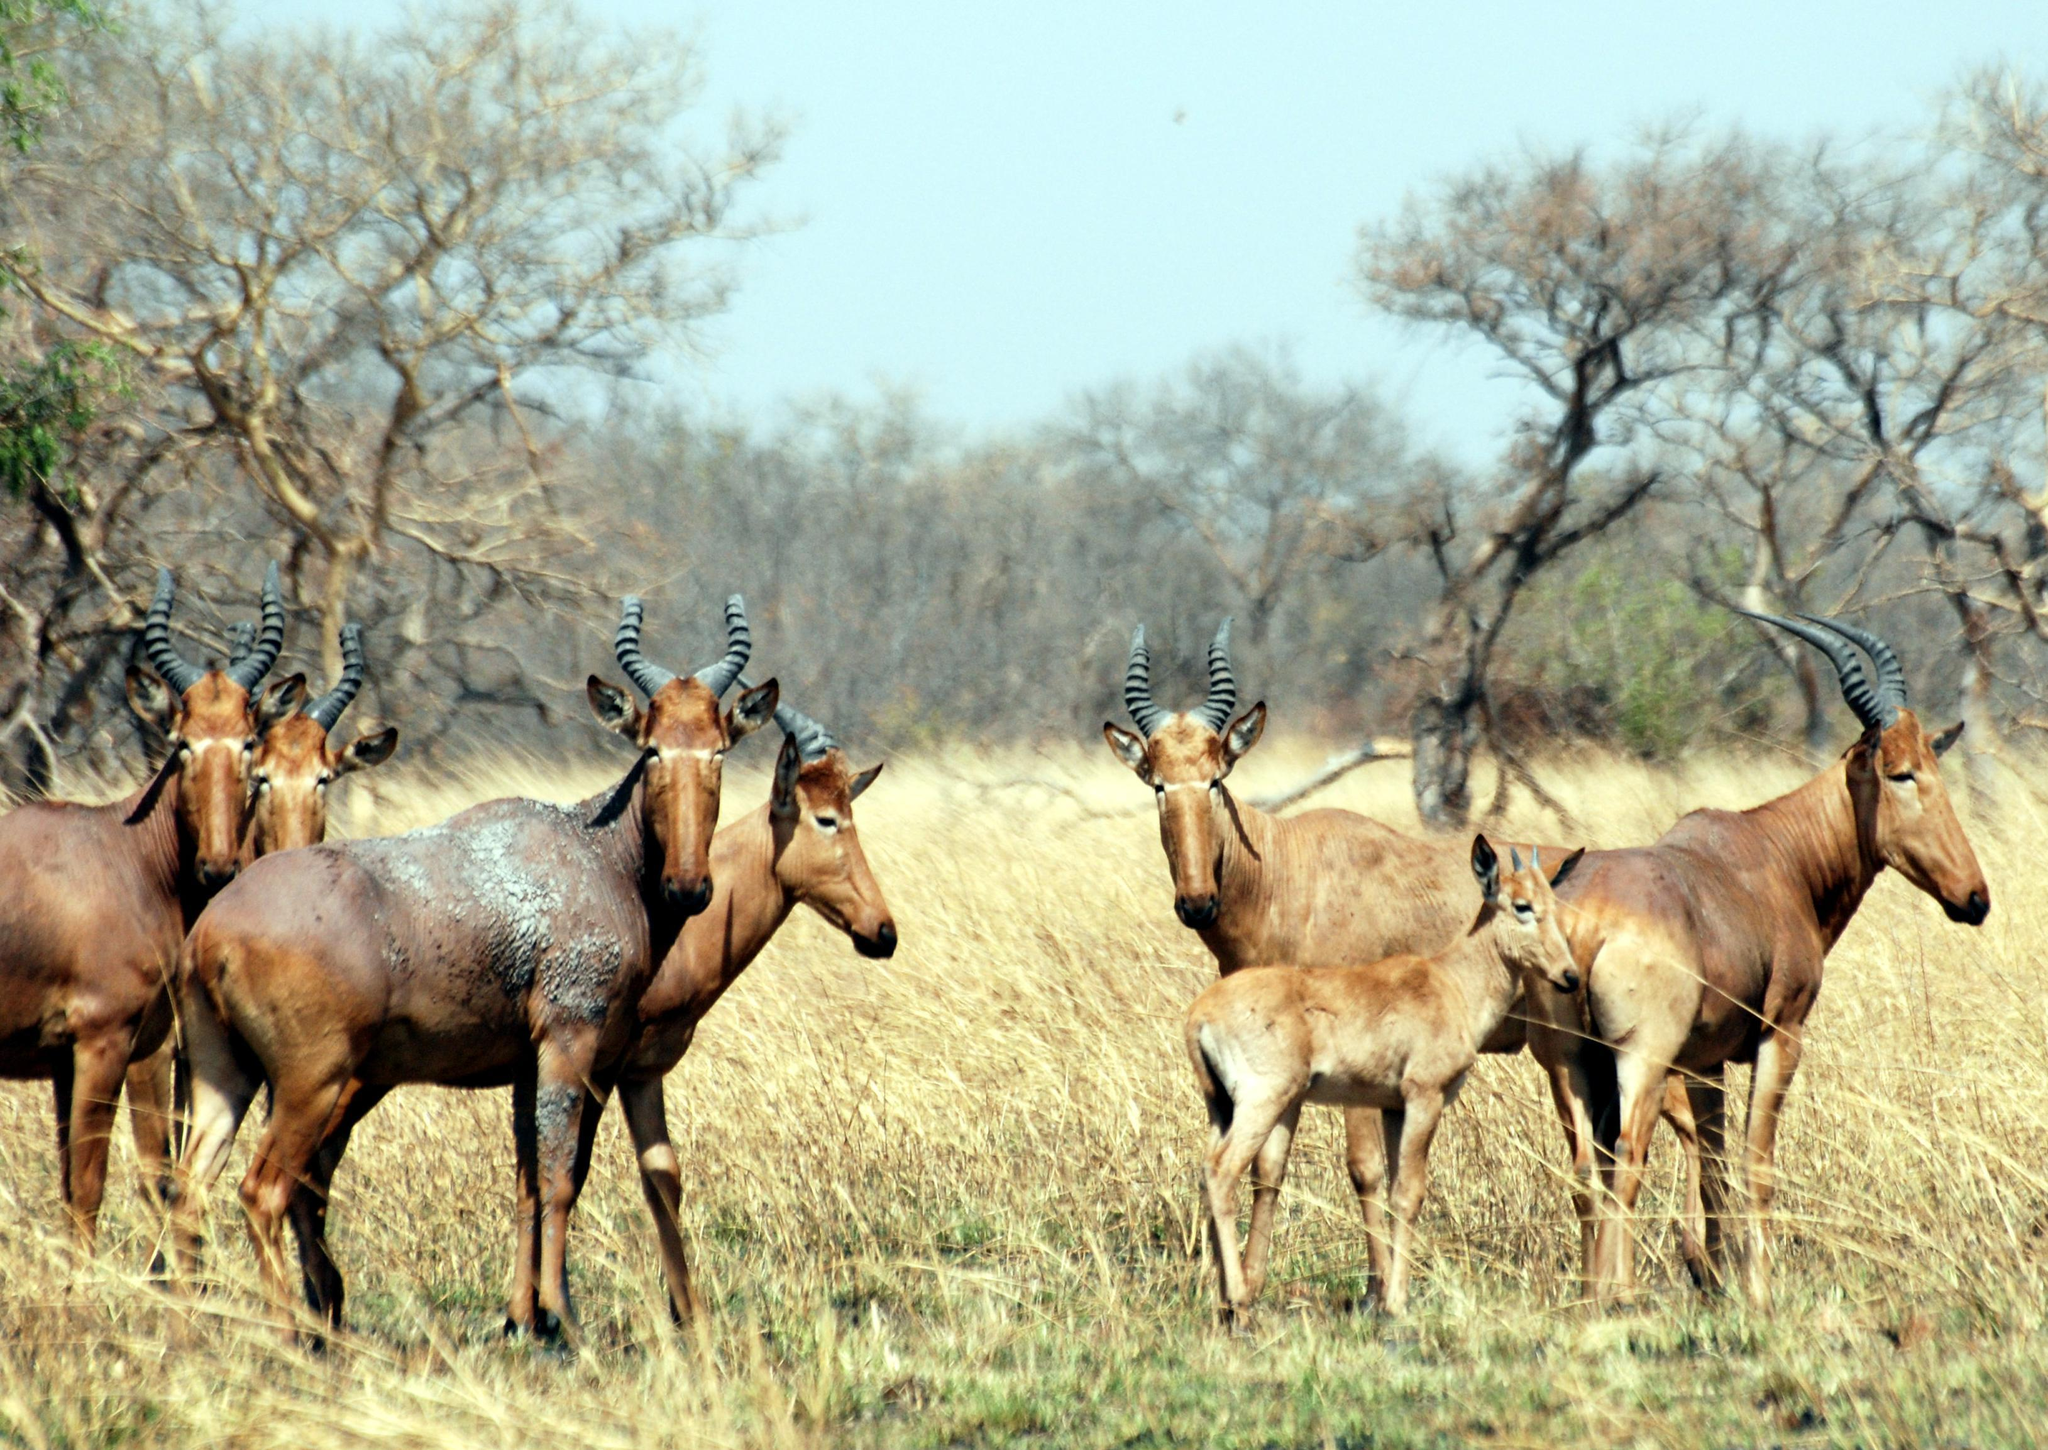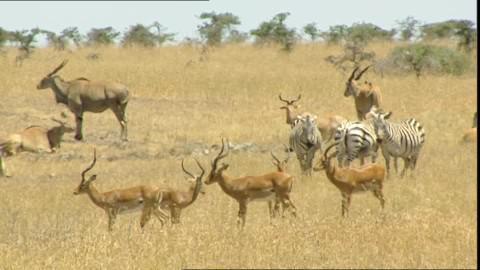The first image is the image on the left, the second image is the image on the right. Evaluate the accuracy of this statement regarding the images: "An image features exactly one horned animal, and it looks toward the camera.". Is it true? Answer yes or no. No. The first image is the image on the left, the second image is the image on the right. Examine the images to the left and right. Is the description "One of the images shows exactly one antelope." accurate? Answer yes or no. No. 